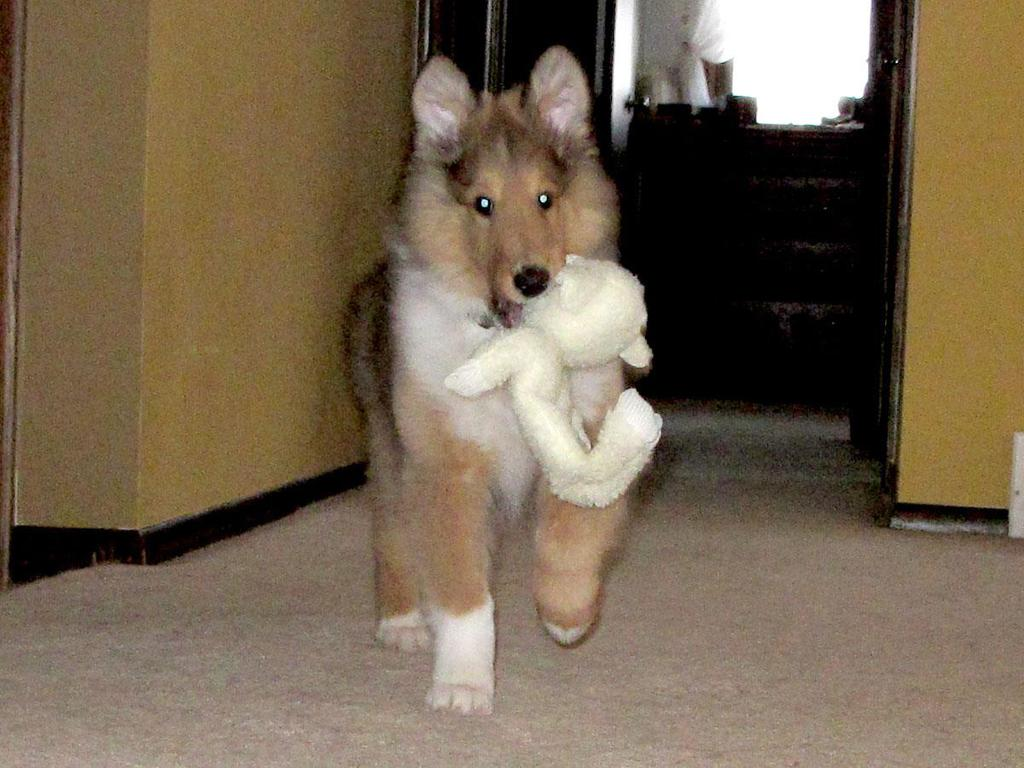What type of animal is in the image? There is a dog in the image in the image. What is the dog doing in the image? The dog is standing in the image. What is the dog holding in the image? The dog is holding a toy in the image. What can be seen in the background of the image? There are objects in the background of the image. What type of writing can be seen on the dog's collar in the image? There is no writing visible on the dog's collar in the image, as the collar is not mentioned in the provided facts. 